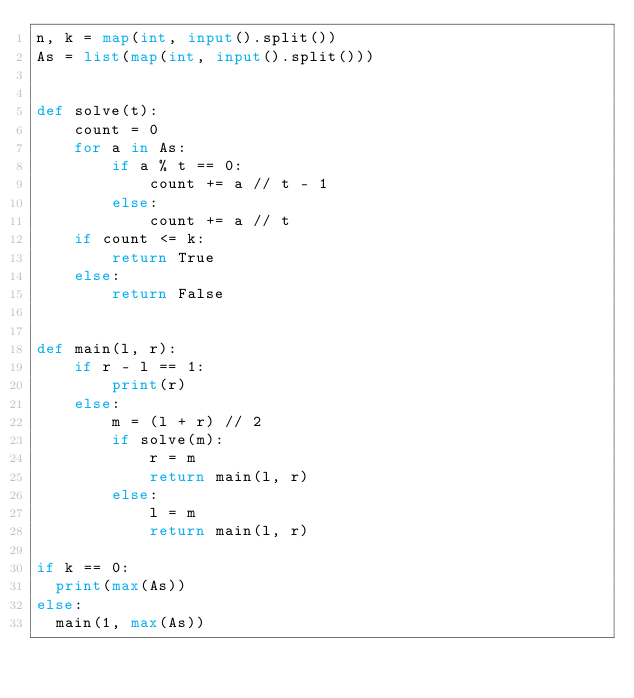Convert code to text. <code><loc_0><loc_0><loc_500><loc_500><_Python_>n, k = map(int, input().split())
As = list(map(int, input().split()))


def solve(t):
    count = 0
    for a in As:
        if a % t == 0:
            count += a // t - 1
        else:
            count += a // t
    if count <= k:
        return True
    else:
        return False


def main(l, r):
    if r - l == 1:
        print(r)
    else:
        m = (l + r) // 2
        if solve(m):
            r = m
            return main(l, r)
        else:
            l = m
            return main(l, r)

if k == 0:
  print(max(As))
else:
  main(1, max(As))
</code> 